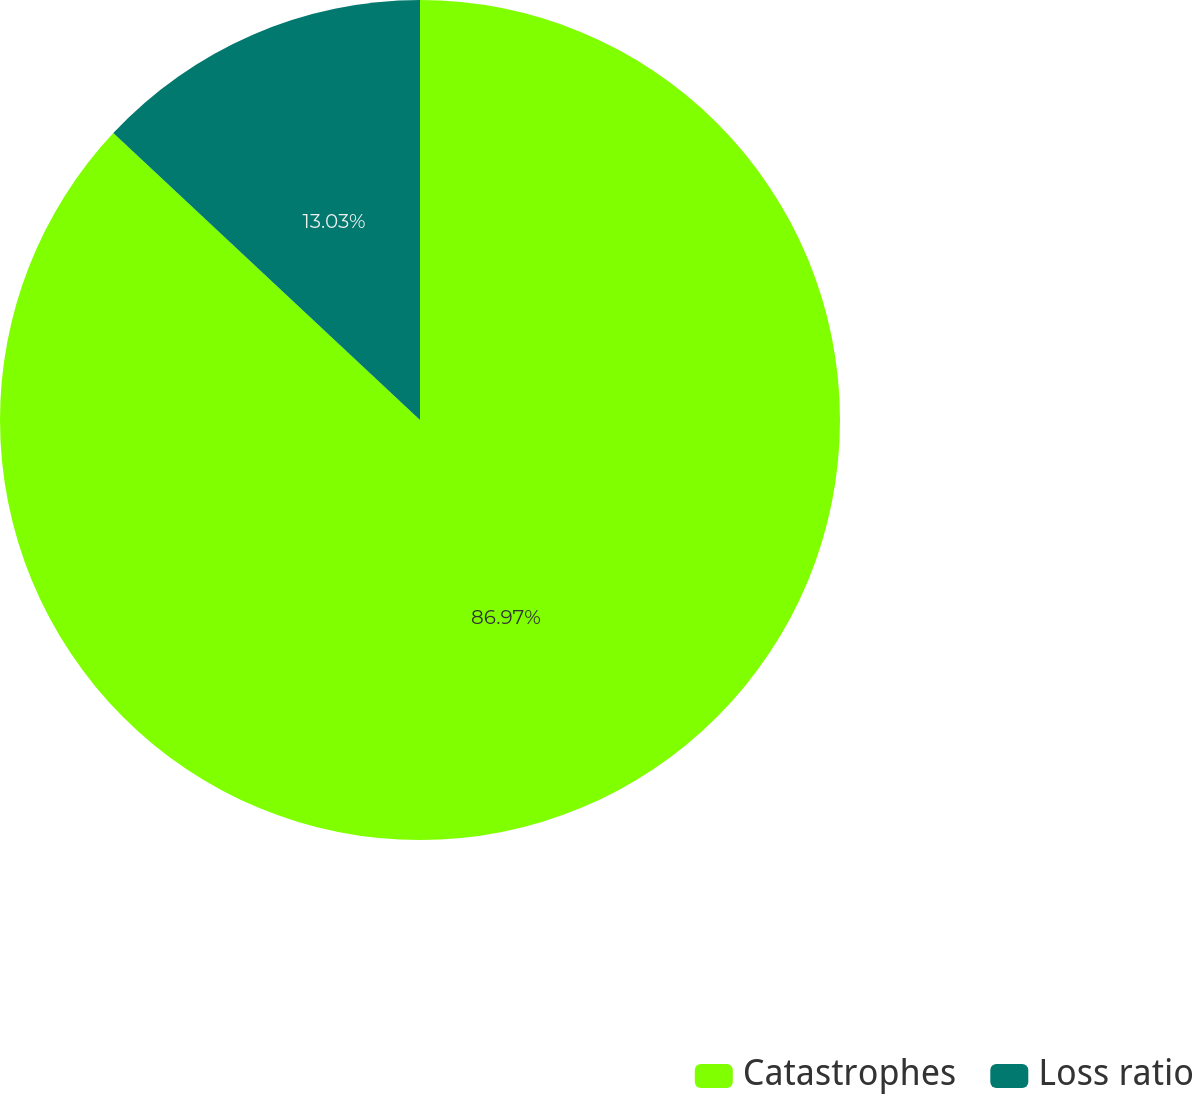Convert chart. <chart><loc_0><loc_0><loc_500><loc_500><pie_chart><fcel>Catastrophes<fcel>Loss ratio<nl><fcel>86.97%<fcel>13.03%<nl></chart> 